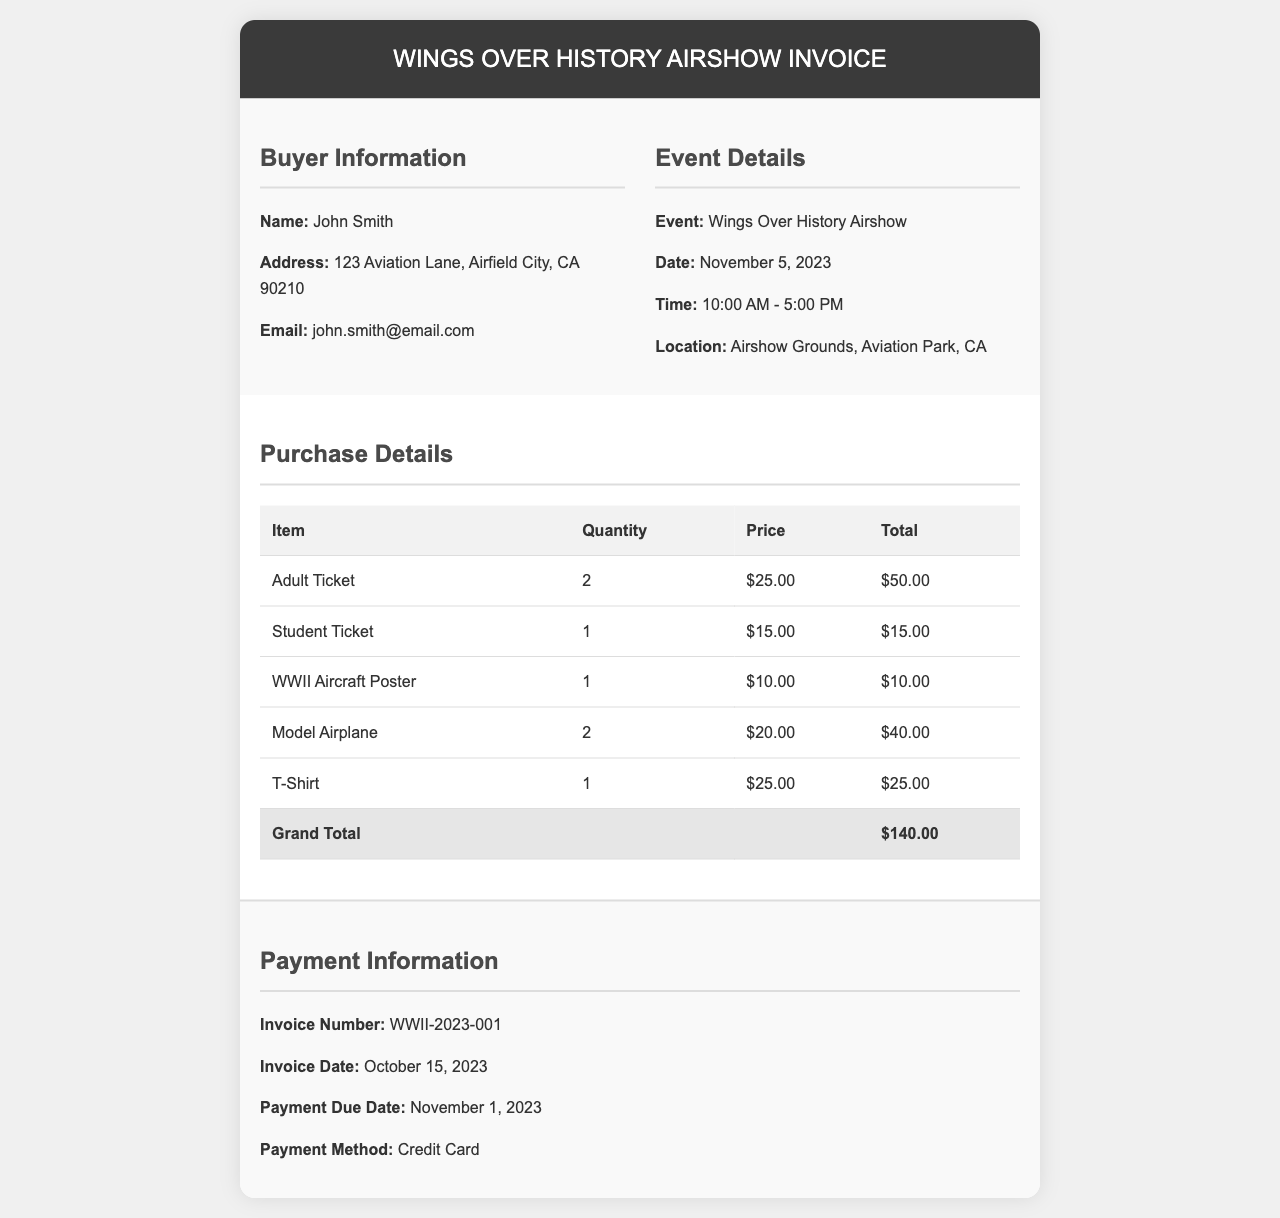What is the buyer's name? The buyer's name is stated under Buyer Information in the document.
Answer: John Smith What is the total number of tickets purchased? The total number of tickets is the sum of Adult and Student tickets in the Purchase Details section.
Answer: 3 What is the date of the event? The date of the event is listed in the Event Details section of the invoice.
Answer: November 5, 2023 What merchandise was bought along with tickets? The merchandise includes items listed in the Purchase Details section, including a poster and a model airplane.
Answer: WWII Aircraft Poster, Model Airplane, T-Shirt What is the grand total amount due? The grand total is found in the Purchase Details section, specifically noted as Grand Total.
Answer: $140.00 What is the payment method used? The payment method is mentioned in the Payment Information section of the invoice.
Answer: Credit Card What is the invoice number? The invoice number is provided in the Payment Information section.
Answer: WWII-2023-001 When is the payment due? The payment due date is stated in the Payment Information section.
Answer: November 1, 2023 